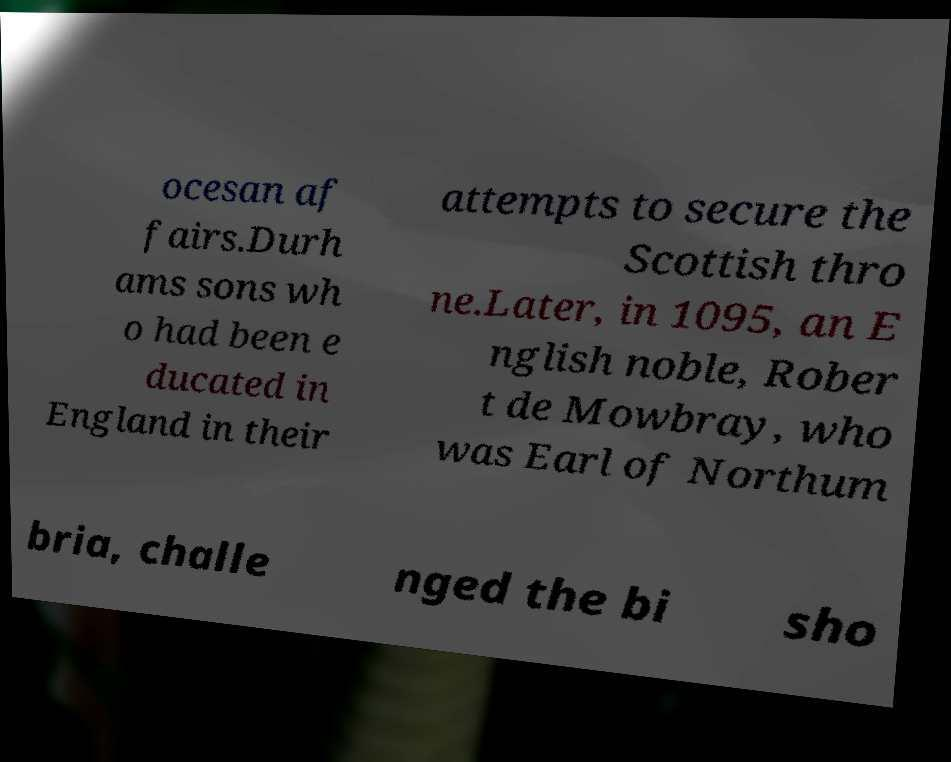Could you extract and type out the text from this image? ocesan af fairs.Durh ams sons wh o had been e ducated in England in their attempts to secure the Scottish thro ne.Later, in 1095, an E nglish noble, Rober t de Mowbray, who was Earl of Northum bria, challe nged the bi sho 